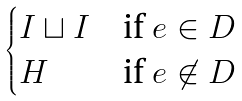<formula> <loc_0><loc_0><loc_500><loc_500>\begin{cases} I \sqcup I & \text {if } e \in D \\ H & \text {if } e \not \in D \end{cases}</formula> 